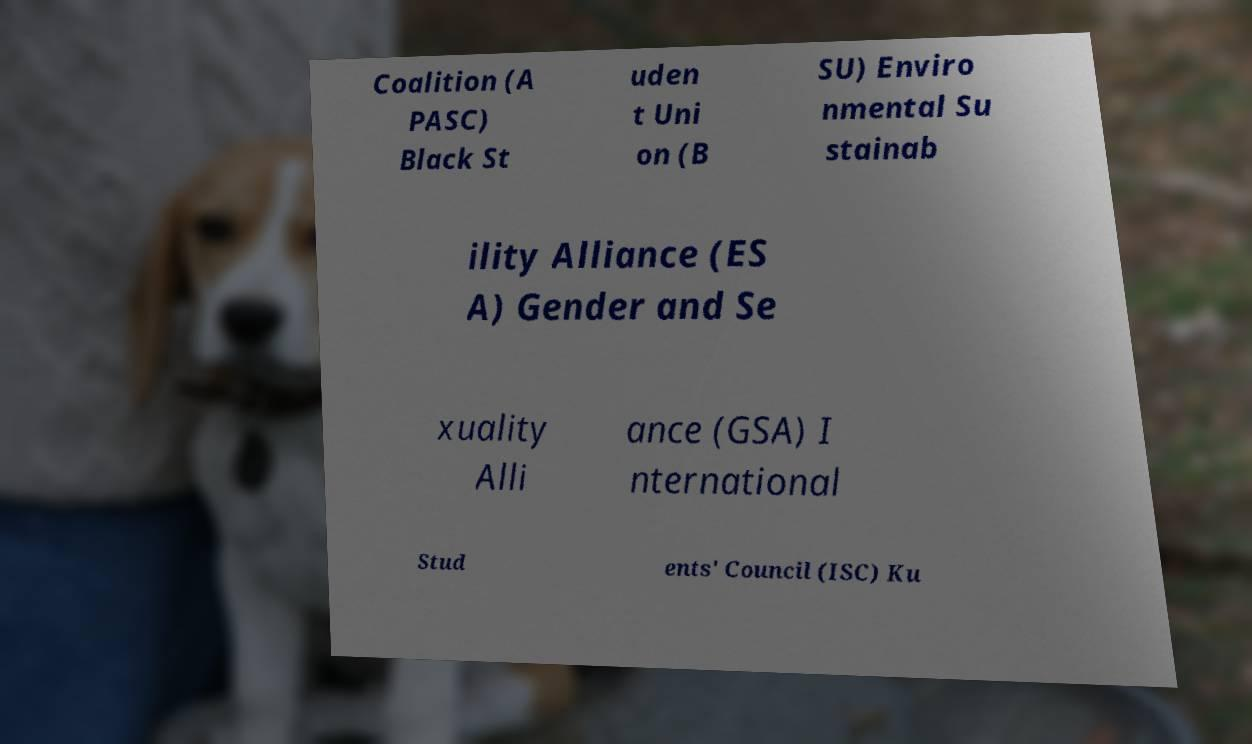There's text embedded in this image that I need extracted. Can you transcribe it verbatim? Coalition (A PASC) Black St uden t Uni on (B SU) Enviro nmental Su stainab ility Alliance (ES A) Gender and Se xuality Alli ance (GSA) I nternational Stud ents' Council (ISC) Ku 